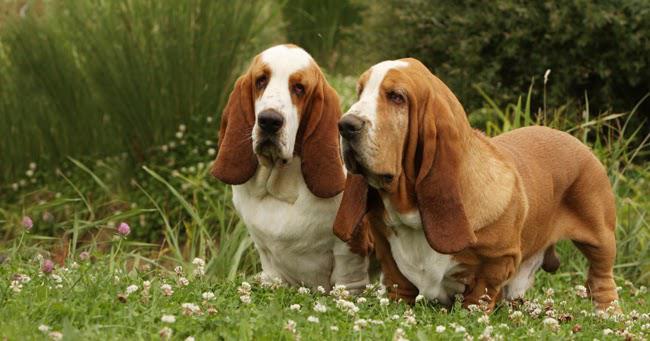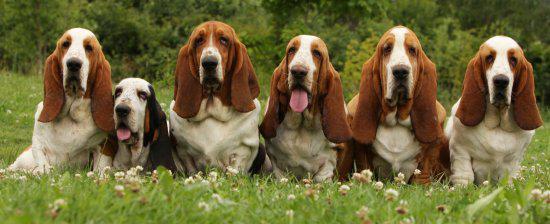The first image is the image on the left, the second image is the image on the right. Examine the images to the left and right. Is the description "One image shows exactly two basset hounds." accurate? Answer yes or no. Yes. 